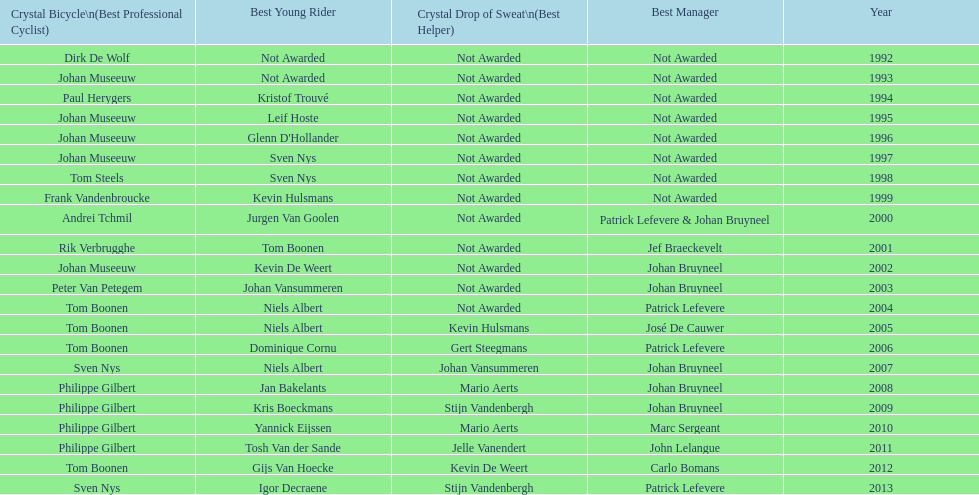Who won the most consecutive crystal bicycles? Philippe Gilbert. Can you parse all the data within this table? {'header': ['Crystal Bicycle\\n(Best Professional Cyclist)', 'Best Young Rider', 'Crystal Drop of Sweat\\n(Best Helper)', 'Best Manager', 'Year'], 'rows': [['Dirk De Wolf', 'Not Awarded', 'Not Awarded', 'Not Awarded', '1992'], ['Johan Museeuw', 'Not Awarded', 'Not Awarded', 'Not Awarded', '1993'], ['Paul Herygers', 'Kristof Trouvé', 'Not Awarded', 'Not Awarded', '1994'], ['Johan Museeuw', 'Leif Hoste', 'Not Awarded', 'Not Awarded', '1995'], ['Johan Museeuw', "Glenn D'Hollander", 'Not Awarded', 'Not Awarded', '1996'], ['Johan Museeuw', 'Sven Nys', 'Not Awarded', 'Not Awarded', '1997'], ['Tom Steels', 'Sven Nys', 'Not Awarded', 'Not Awarded', '1998'], ['Frank Vandenbroucke', 'Kevin Hulsmans', 'Not Awarded', 'Not Awarded', '1999'], ['Andrei Tchmil', 'Jurgen Van Goolen', 'Not Awarded', 'Patrick Lefevere & Johan Bruyneel', '2000'], ['Rik Verbrugghe', 'Tom Boonen', 'Not Awarded', 'Jef Braeckevelt', '2001'], ['Johan Museeuw', 'Kevin De Weert', 'Not Awarded', 'Johan Bruyneel', '2002'], ['Peter Van Petegem', 'Johan Vansummeren', 'Not Awarded', 'Johan Bruyneel', '2003'], ['Tom Boonen', 'Niels Albert', 'Not Awarded', 'Patrick Lefevere', '2004'], ['Tom Boonen', 'Niels Albert', 'Kevin Hulsmans', 'José De Cauwer', '2005'], ['Tom Boonen', 'Dominique Cornu', 'Gert Steegmans', 'Patrick Lefevere', '2006'], ['Sven Nys', 'Niels Albert', 'Johan Vansummeren', 'Johan Bruyneel', '2007'], ['Philippe Gilbert', 'Jan Bakelants', 'Mario Aerts', 'Johan Bruyneel', '2008'], ['Philippe Gilbert', 'Kris Boeckmans', 'Stijn Vandenbergh', 'Johan Bruyneel', '2009'], ['Philippe Gilbert', 'Yannick Eijssen', 'Mario Aerts', 'Marc Sergeant', '2010'], ['Philippe Gilbert', 'Tosh Van der Sande', 'Jelle Vanendert', 'John Lelangue', '2011'], ['Tom Boonen', 'Gijs Van Hoecke', 'Kevin De Weert', 'Carlo Bomans', '2012'], ['Sven Nys', 'Igor Decraene', 'Stijn Vandenbergh', 'Patrick Lefevere', '2013']]} 